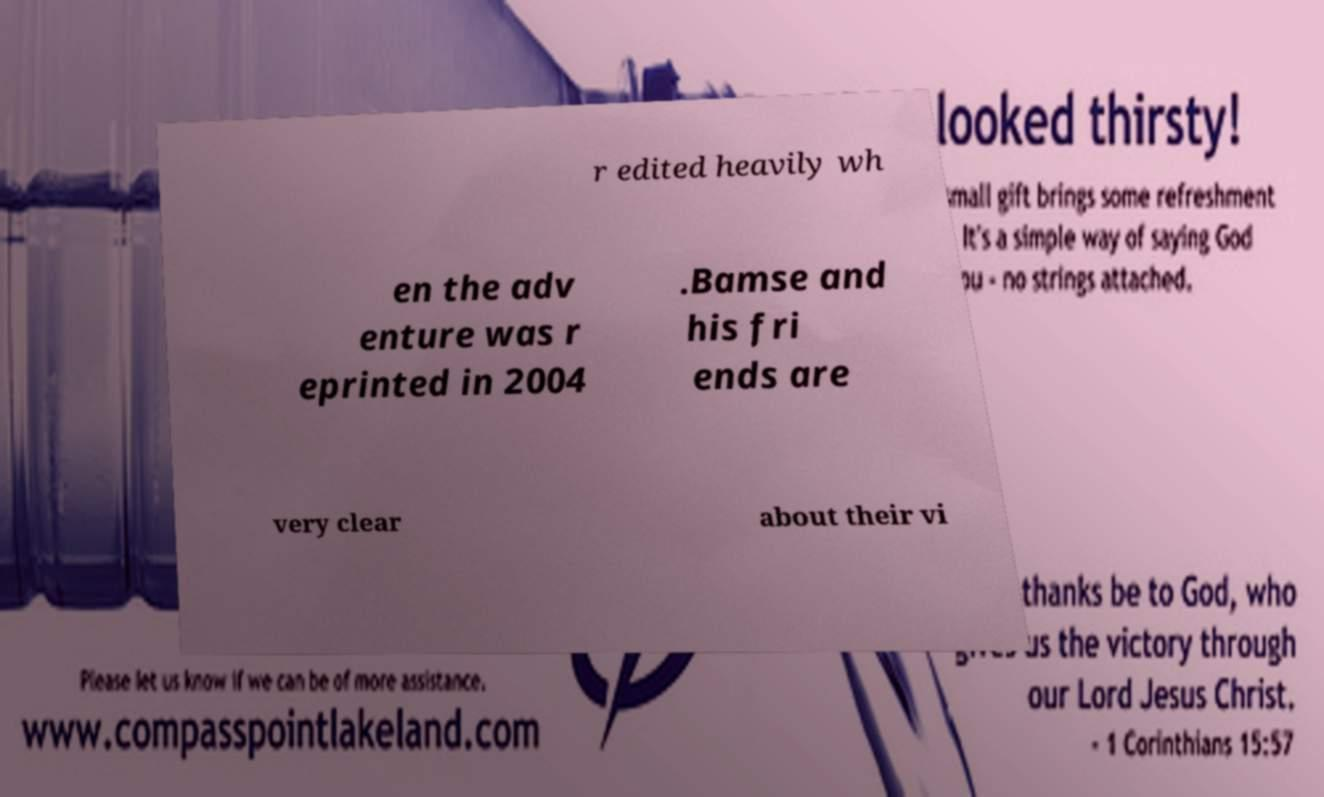Could you assist in decoding the text presented in this image and type it out clearly? r edited heavily wh en the adv enture was r eprinted in 2004 .Bamse and his fri ends are very clear about their vi 